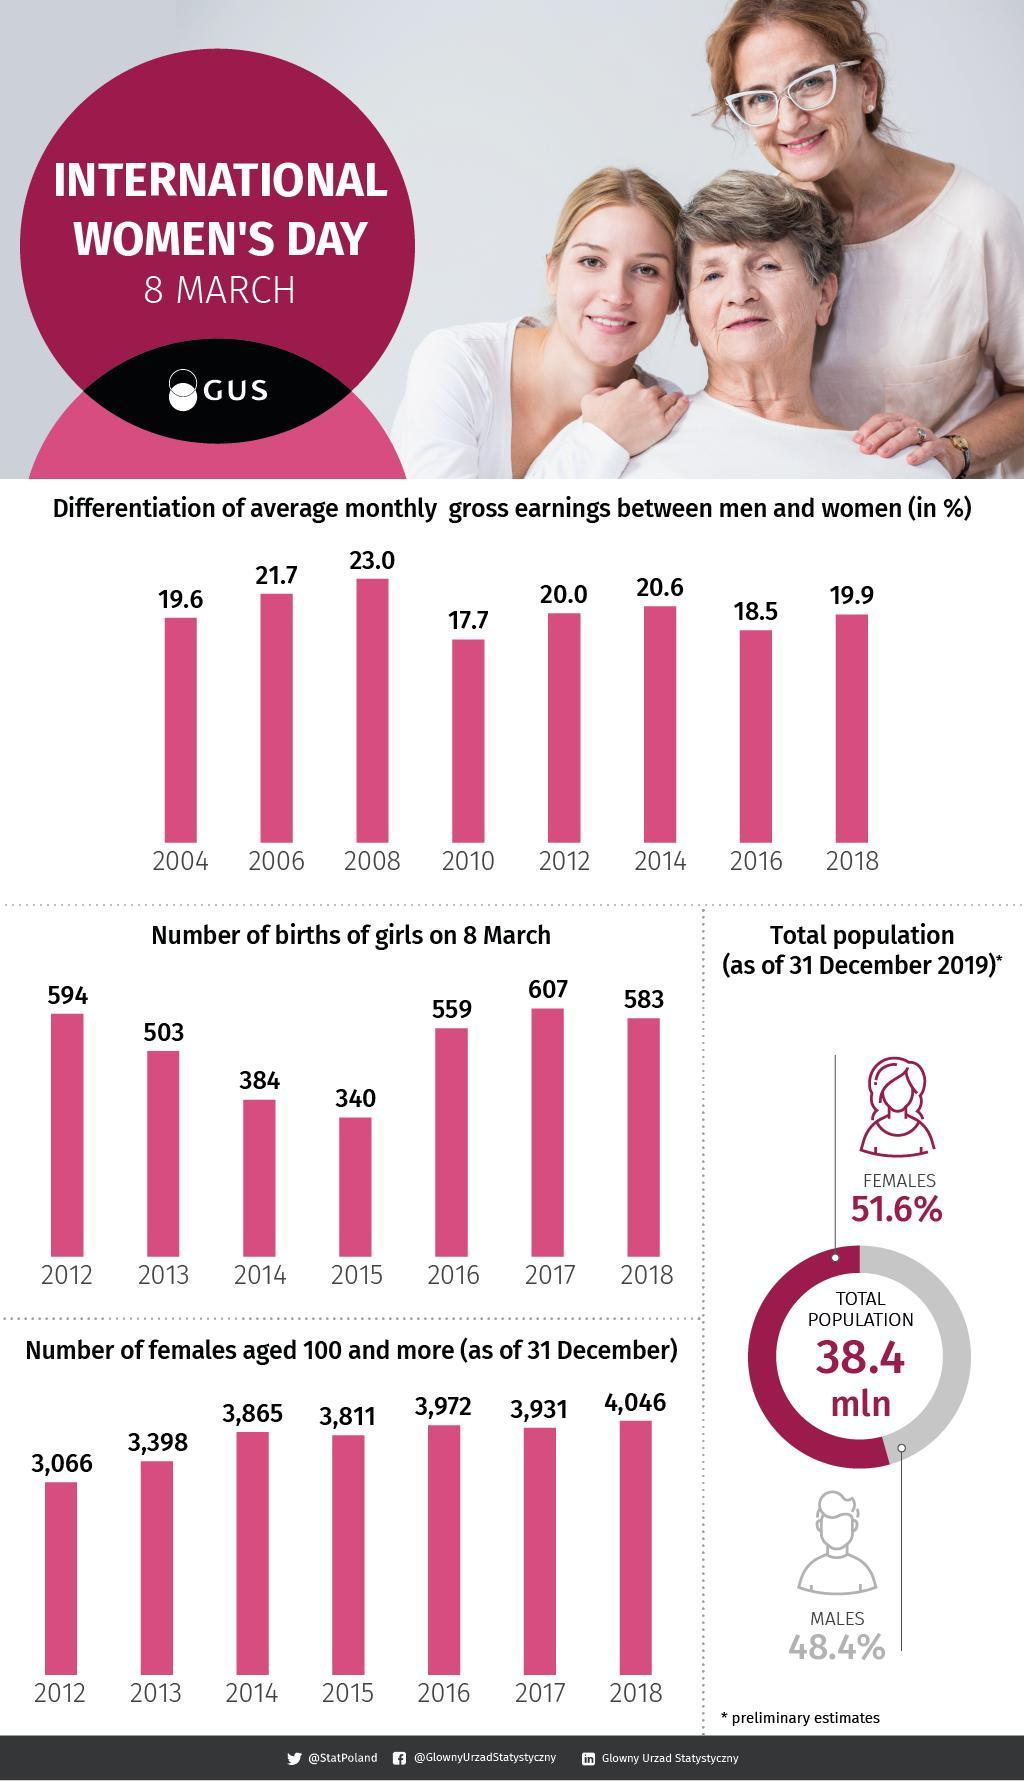What is the number of births of girls on March 8 in 2016 and 2017, taken together?
Answer the question with a short phrase. 1166 What is the number of females aged 100 and more in 2016 and 2017, taken together? 7903 What is the number of births of girls on March 8 in 2012 and 2018, taken together? 1177 What is the number of births of girls on March 8 in 2014 and 2015, taken together? 724 What is the number of births of girls on March 8 in 2012 and 2013, taken together? 1097 What is the number of females aged 100 and more in 2012 and 2018, taken together? 7112 What is the number of females aged 100 and more in 2012 and 2013, taken together? 6464 What is the number of females aged 100 and more in 2014 and 2015, taken together? 7676 